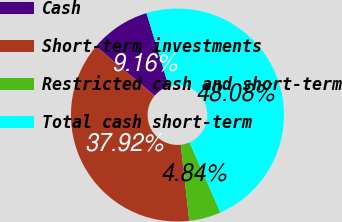<chart> <loc_0><loc_0><loc_500><loc_500><pie_chart><fcel>Cash<fcel>Short-term investments<fcel>Restricted cash and short-term<fcel>Total cash short-term<nl><fcel>9.16%<fcel>37.92%<fcel>4.84%<fcel>48.08%<nl></chart> 